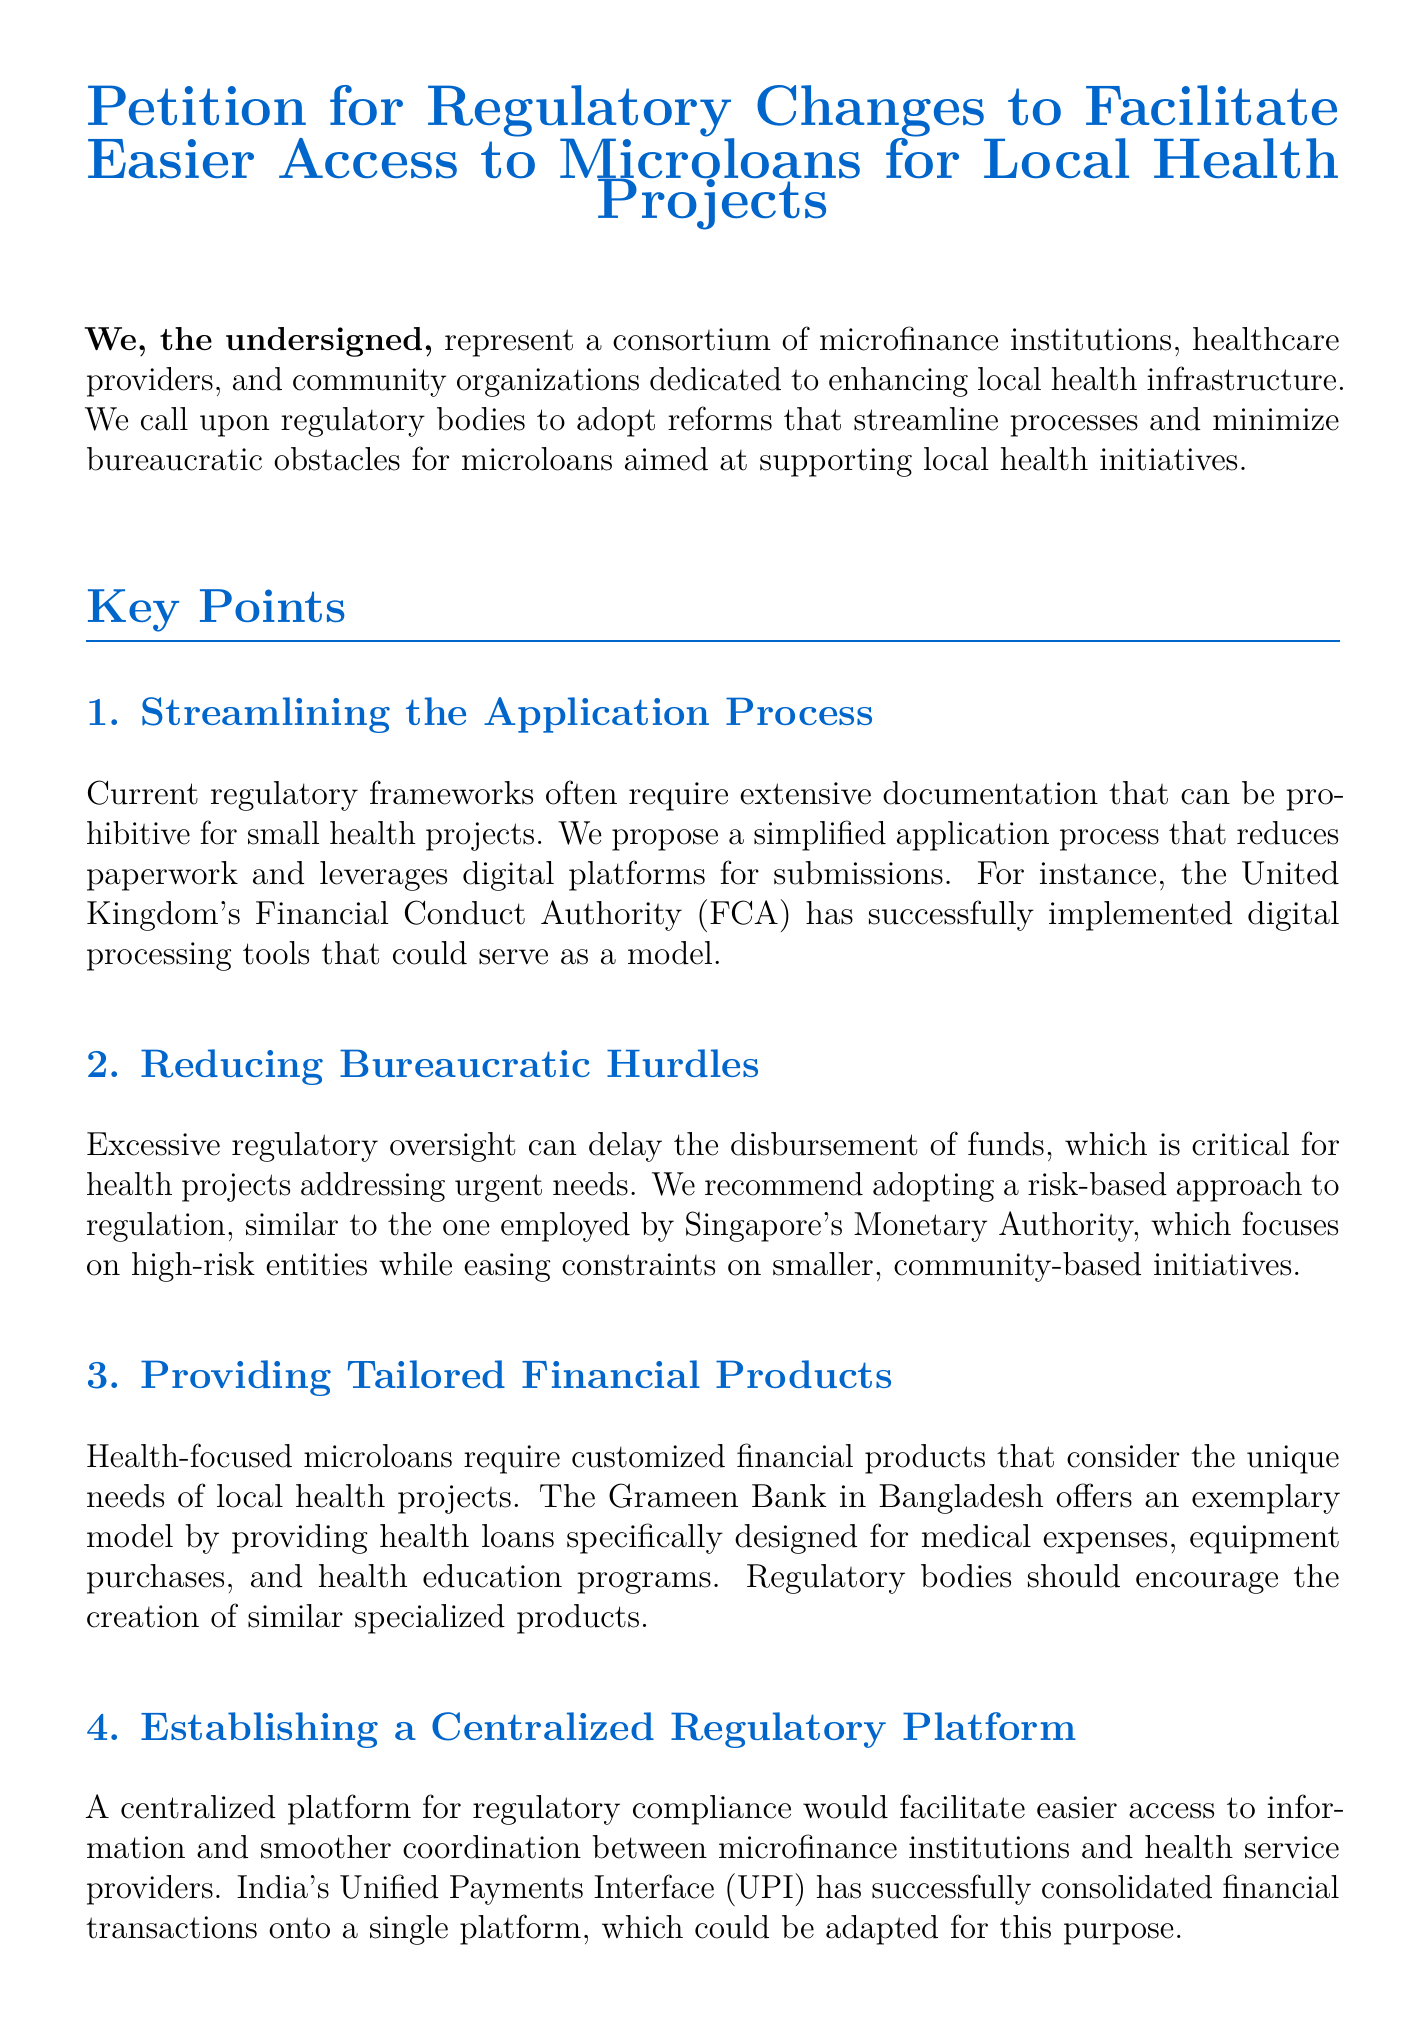What is the main goal of the petition? The main goal of the petition is to call for regulatory reforms that streamline processes for microloans aimed at local health initiatives.
Answer: Regulatory reforms Who is signing the petition? The petition is signed by a consortium of microfinance institutions, healthcare providers, and community organizations.
Answer: Consortium What does the petition propose for the application process? The petition proposes a simplified application process that reduces paperwork and uses digital platforms for submissions.
Answer: Simplified application process Which country's regulatory approach is referenced as a model in the petition? The regulatory approach of the United Kingdom's Financial Conduct Authority is mentioned as a model.
Answer: United Kingdom What type of approach does the petition recommend for reducing bureaucratic hurdles? The petition recommends adopting a risk-based approach to regulation.
Answer: Risk-based approach What is a suggested feature of tailored financial products mentioned in the petition? Customized financial products should consider the unique needs of local health projects.
Answer: Customized financial products What successful model is cited for establishing a centralized regulatory platform? India's Unified Payments Interface (UPI) is cited as a successful model.
Answer: Unified Payments Interface (UPI) What incentives are suggested to encourage public-private partnerships? The petition suggests incentives such as subsidies and tax breaks.
Answer: Subsidies and tax breaks 